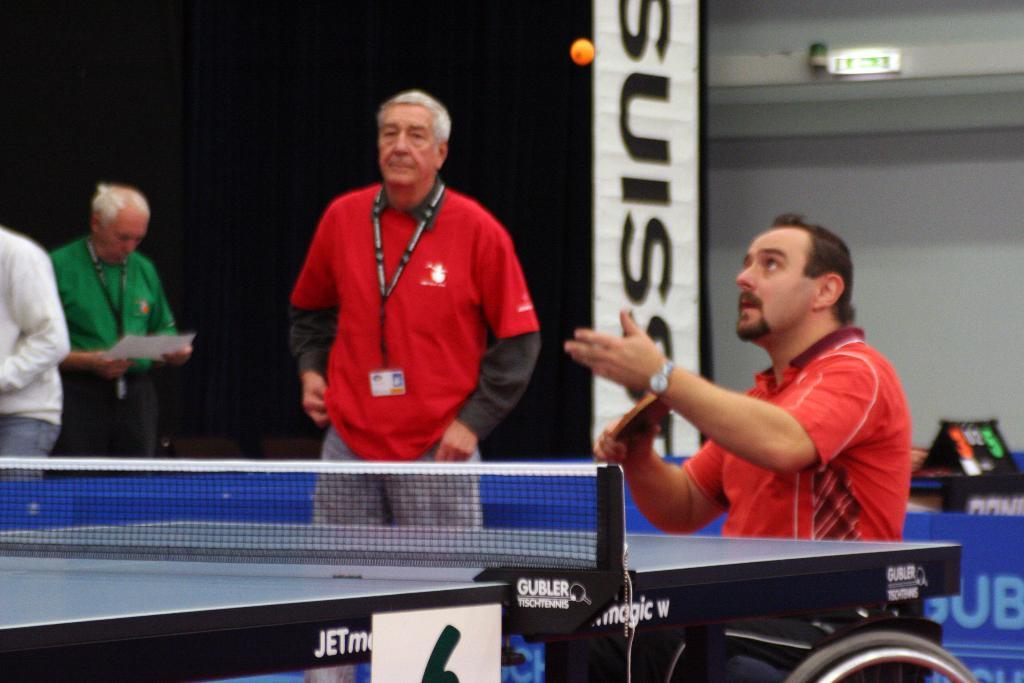What is the color of the wall in the image? The wall in the image is white. What can be seen hanging on the wall? There is a banner in the image. How many people are present in the image? There are four people in the image. What object is visible in the image that might be used for catching or blocking? There is a net in the image. Is there a circle drawn on the street in the image? There is no street or circle present in the image. 